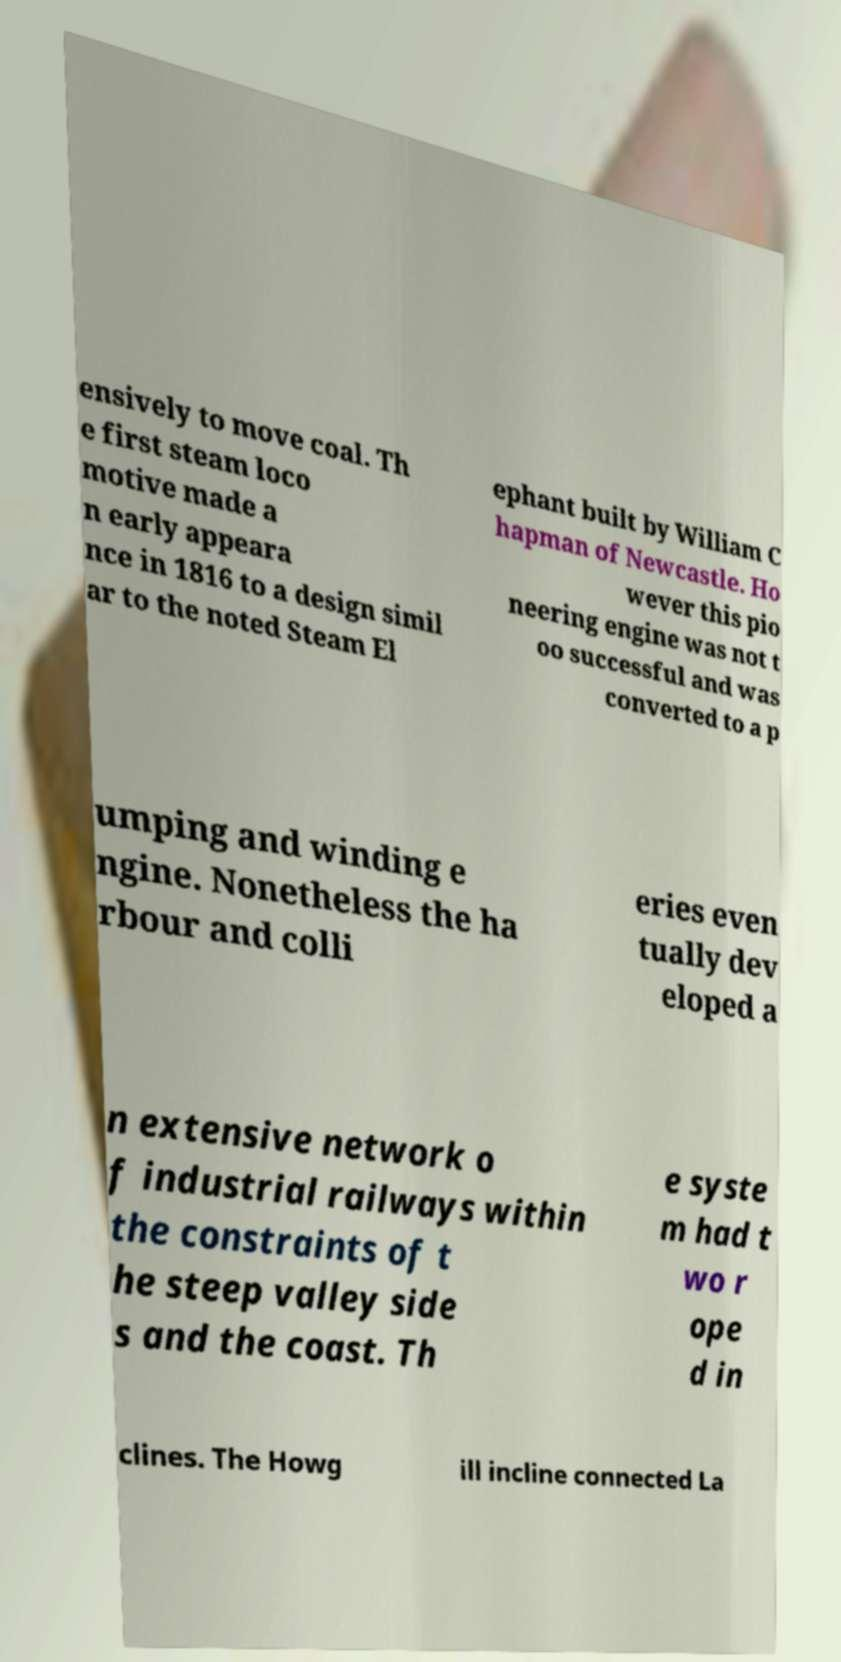Can you accurately transcribe the text from the provided image for me? ensively to move coal. Th e first steam loco motive made a n early appeara nce in 1816 to a design simil ar to the noted Steam El ephant built by William C hapman of Newcastle. Ho wever this pio neering engine was not t oo successful and was converted to a p umping and winding e ngine. Nonetheless the ha rbour and colli eries even tually dev eloped a n extensive network o f industrial railways within the constraints of t he steep valley side s and the coast. Th e syste m had t wo r ope d in clines. The Howg ill incline connected La 